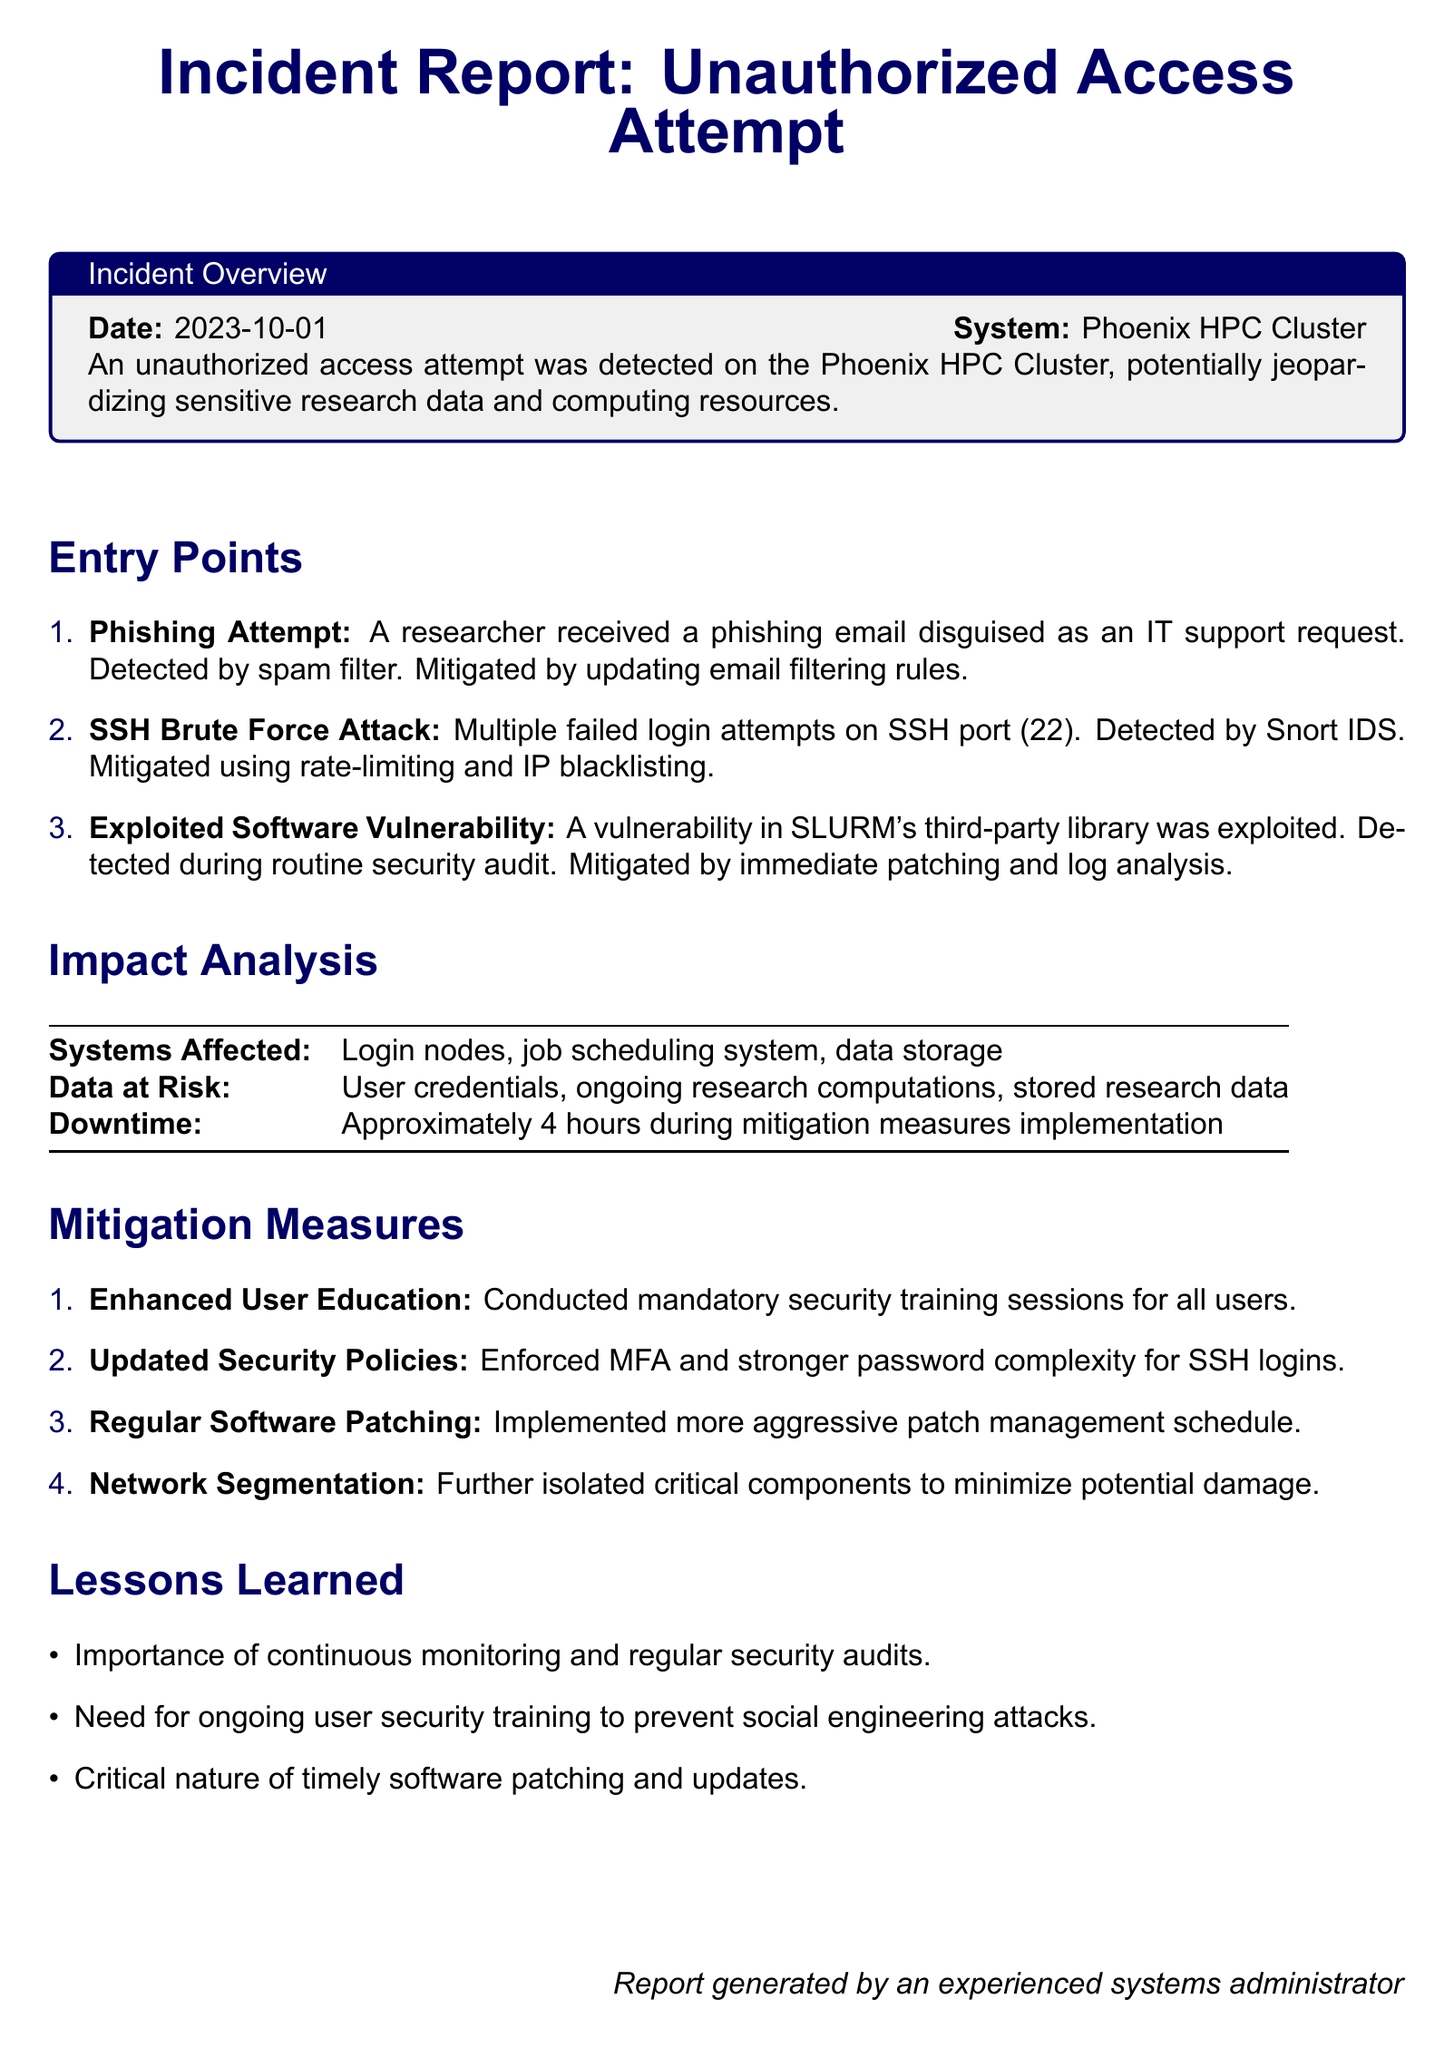What is the date of the incident? The date is specified in the Incident Overview section of the document.
Answer: 2023-10-01 What system was affected during the unauthorized access attempt? The system is listed in the Incident Overview section.
Answer: Phoenix HPC Cluster How many entry points were identified? The number of entry points is stated explicitly in the Entry Points section of the document.
Answer: 3 What was the outcome for the affected systems? The impact on systems is detailed in the Impact Analysis section, specifically regarding login nodes and job scheduling.
Answer: Login nodes, job scheduling system, data storage What mitigation measure was implemented for user security? This information is found in the Mitigation Measures section, where user education is mentioned.
Answer: Enhanced User Education How long was the downtime due to mitigation measures? The downtime is provided in the Impact Analysis section.
Answer: Approximately 4 hours What type of attack involved failed SSH login attempts? The specific attack type is detailed in the Entry Points section regarding failed login attempts.
Answer: SSH Brute Force Attack What did the incident report highlight as a lesson learned? One of the lessons learned is mentioned under the Lessons Learned section.
Answer: Importance of continuous monitoring and regular security audits What policy was updated to enhance security? The specific policy change is listed in the Mitigation Measures section.
Answer: Updated Security Policies 